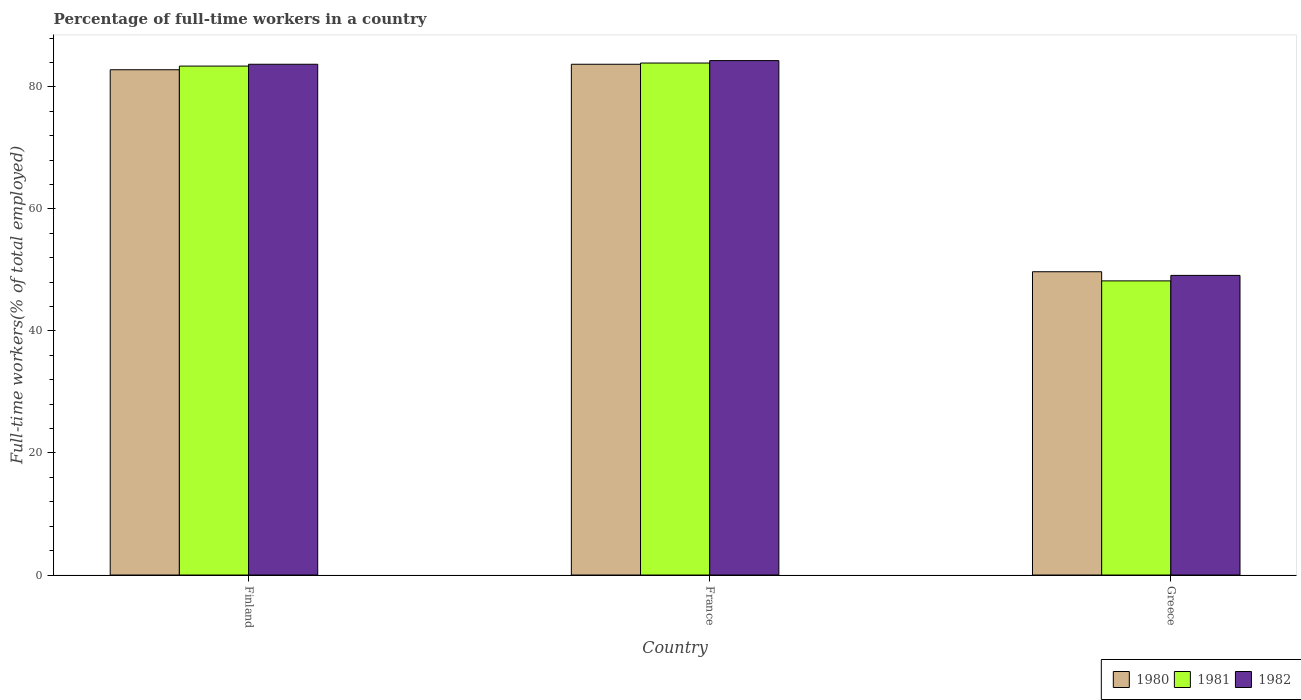How many different coloured bars are there?
Ensure brevity in your answer.  3. How many groups of bars are there?
Offer a terse response. 3. How many bars are there on the 3rd tick from the right?
Your response must be concise. 3. What is the label of the 2nd group of bars from the left?
Offer a very short reply. France. What is the percentage of full-time workers in 1980 in France?
Make the answer very short. 83.7. Across all countries, what is the maximum percentage of full-time workers in 1982?
Your answer should be compact. 84.3. Across all countries, what is the minimum percentage of full-time workers in 1982?
Your answer should be compact. 49.1. In which country was the percentage of full-time workers in 1982 maximum?
Ensure brevity in your answer.  France. What is the total percentage of full-time workers in 1980 in the graph?
Give a very brief answer. 216.2. What is the difference between the percentage of full-time workers in 1981 in Finland and that in Greece?
Offer a terse response. 35.2. What is the difference between the percentage of full-time workers in 1981 in Greece and the percentage of full-time workers in 1982 in France?
Your answer should be very brief. -36.1. What is the average percentage of full-time workers in 1981 per country?
Ensure brevity in your answer.  71.83. What is the difference between the percentage of full-time workers of/in 1980 and percentage of full-time workers of/in 1982 in Greece?
Make the answer very short. 0.6. What is the ratio of the percentage of full-time workers in 1980 in France to that in Greece?
Your answer should be very brief. 1.68. Is the percentage of full-time workers in 1982 in Finland less than that in France?
Give a very brief answer. Yes. Is the difference between the percentage of full-time workers in 1980 in Finland and France greater than the difference between the percentage of full-time workers in 1982 in Finland and France?
Offer a terse response. No. What is the difference between the highest and the second highest percentage of full-time workers in 1982?
Offer a terse response. -34.6. What is the difference between the highest and the lowest percentage of full-time workers in 1981?
Provide a succinct answer. 35.7. Is the sum of the percentage of full-time workers in 1981 in Finland and Greece greater than the maximum percentage of full-time workers in 1980 across all countries?
Offer a terse response. Yes. Are the values on the major ticks of Y-axis written in scientific E-notation?
Provide a short and direct response. No. Where does the legend appear in the graph?
Make the answer very short. Bottom right. How many legend labels are there?
Your answer should be compact. 3. How are the legend labels stacked?
Offer a terse response. Horizontal. What is the title of the graph?
Provide a succinct answer. Percentage of full-time workers in a country. Does "2004" appear as one of the legend labels in the graph?
Your response must be concise. No. What is the label or title of the X-axis?
Offer a very short reply. Country. What is the label or title of the Y-axis?
Provide a succinct answer. Full-time workers(% of total employed). What is the Full-time workers(% of total employed) of 1980 in Finland?
Keep it short and to the point. 82.8. What is the Full-time workers(% of total employed) of 1981 in Finland?
Ensure brevity in your answer.  83.4. What is the Full-time workers(% of total employed) of 1982 in Finland?
Give a very brief answer. 83.7. What is the Full-time workers(% of total employed) of 1980 in France?
Ensure brevity in your answer.  83.7. What is the Full-time workers(% of total employed) in 1981 in France?
Your response must be concise. 83.9. What is the Full-time workers(% of total employed) of 1982 in France?
Keep it short and to the point. 84.3. What is the Full-time workers(% of total employed) in 1980 in Greece?
Keep it short and to the point. 49.7. What is the Full-time workers(% of total employed) in 1981 in Greece?
Keep it short and to the point. 48.2. What is the Full-time workers(% of total employed) of 1982 in Greece?
Provide a succinct answer. 49.1. Across all countries, what is the maximum Full-time workers(% of total employed) of 1980?
Provide a short and direct response. 83.7. Across all countries, what is the maximum Full-time workers(% of total employed) in 1981?
Your response must be concise. 83.9. Across all countries, what is the maximum Full-time workers(% of total employed) in 1982?
Your answer should be very brief. 84.3. Across all countries, what is the minimum Full-time workers(% of total employed) in 1980?
Ensure brevity in your answer.  49.7. Across all countries, what is the minimum Full-time workers(% of total employed) in 1981?
Give a very brief answer. 48.2. Across all countries, what is the minimum Full-time workers(% of total employed) of 1982?
Ensure brevity in your answer.  49.1. What is the total Full-time workers(% of total employed) in 1980 in the graph?
Offer a very short reply. 216.2. What is the total Full-time workers(% of total employed) of 1981 in the graph?
Offer a terse response. 215.5. What is the total Full-time workers(% of total employed) in 1982 in the graph?
Provide a succinct answer. 217.1. What is the difference between the Full-time workers(% of total employed) in 1982 in Finland and that in France?
Your answer should be very brief. -0.6. What is the difference between the Full-time workers(% of total employed) in 1980 in Finland and that in Greece?
Provide a short and direct response. 33.1. What is the difference between the Full-time workers(% of total employed) of 1981 in Finland and that in Greece?
Provide a short and direct response. 35.2. What is the difference between the Full-time workers(% of total employed) in 1982 in Finland and that in Greece?
Provide a succinct answer. 34.6. What is the difference between the Full-time workers(% of total employed) in 1980 in France and that in Greece?
Your response must be concise. 34. What is the difference between the Full-time workers(% of total employed) of 1981 in France and that in Greece?
Your answer should be very brief. 35.7. What is the difference between the Full-time workers(% of total employed) in 1982 in France and that in Greece?
Ensure brevity in your answer.  35.2. What is the difference between the Full-time workers(% of total employed) of 1981 in Finland and the Full-time workers(% of total employed) of 1982 in France?
Your answer should be very brief. -0.9. What is the difference between the Full-time workers(% of total employed) in 1980 in Finland and the Full-time workers(% of total employed) in 1981 in Greece?
Ensure brevity in your answer.  34.6. What is the difference between the Full-time workers(% of total employed) of 1980 in Finland and the Full-time workers(% of total employed) of 1982 in Greece?
Provide a succinct answer. 33.7. What is the difference between the Full-time workers(% of total employed) of 1981 in Finland and the Full-time workers(% of total employed) of 1982 in Greece?
Provide a succinct answer. 34.3. What is the difference between the Full-time workers(% of total employed) of 1980 in France and the Full-time workers(% of total employed) of 1981 in Greece?
Offer a terse response. 35.5. What is the difference between the Full-time workers(% of total employed) in 1980 in France and the Full-time workers(% of total employed) in 1982 in Greece?
Give a very brief answer. 34.6. What is the difference between the Full-time workers(% of total employed) in 1981 in France and the Full-time workers(% of total employed) in 1982 in Greece?
Offer a terse response. 34.8. What is the average Full-time workers(% of total employed) of 1980 per country?
Your answer should be compact. 72.07. What is the average Full-time workers(% of total employed) of 1981 per country?
Provide a succinct answer. 71.83. What is the average Full-time workers(% of total employed) of 1982 per country?
Make the answer very short. 72.37. What is the difference between the Full-time workers(% of total employed) in 1980 and Full-time workers(% of total employed) in 1981 in France?
Give a very brief answer. -0.2. What is the difference between the Full-time workers(% of total employed) of 1981 and Full-time workers(% of total employed) of 1982 in France?
Give a very brief answer. -0.4. What is the difference between the Full-time workers(% of total employed) of 1980 and Full-time workers(% of total employed) of 1981 in Greece?
Offer a very short reply. 1.5. What is the difference between the Full-time workers(% of total employed) in 1980 and Full-time workers(% of total employed) in 1982 in Greece?
Offer a very short reply. 0.6. What is the difference between the Full-time workers(% of total employed) in 1981 and Full-time workers(% of total employed) in 1982 in Greece?
Your answer should be compact. -0.9. What is the ratio of the Full-time workers(% of total employed) in 1980 in Finland to that in France?
Offer a terse response. 0.99. What is the ratio of the Full-time workers(% of total employed) in 1980 in Finland to that in Greece?
Your answer should be compact. 1.67. What is the ratio of the Full-time workers(% of total employed) of 1981 in Finland to that in Greece?
Your response must be concise. 1.73. What is the ratio of the Full-time workers(% of total employed) of 1982 in Finland to that in Greece?
Your response must be concise. 1.7. What is the ratio of the Full-time workers(% of total employed) in 1980 in France to that in Greece?
Your response must be concise. 1.68. What is the ratio of the Full-time workers(% of total employed) in 1981 in France to that in Greece?
Give a very brief answer. 1.74. What is the ratio of the Full-time workers(% of total employed) of 1982 in France to that in Greece?
Keep it short and to the point. 1.72. What is the difference between the highest and the second highest Full-time workers(% of total employed) in 1982?
Offer a very short reply. 0.6. What is the difference between the highest and the lowest Full-time workers(% of total employed) of 1981?
Your response must be concise. 35.7. What is the difference between the highest and the lowest Full-time workers(% of total employed) in 1982?
Make the answer very short. 35.2. 